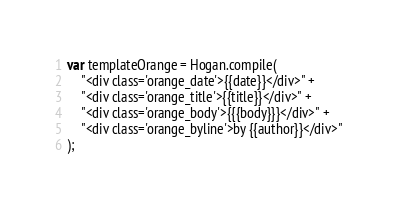Convert code to text. <code><loc_0><loc_0><loc_500><loc_500><_JavaScript_>
var templateOrange = Hogan.compile(
	"<div class='orange_date'>{{date}}</div>" +
	"<div class='orange_title'>{{title}}</div>" +
	"<div class='orange_body'>{{{body}}}</div>" +
	"<div class='orange_byline'>by {{author}}</div>"
);</code> 